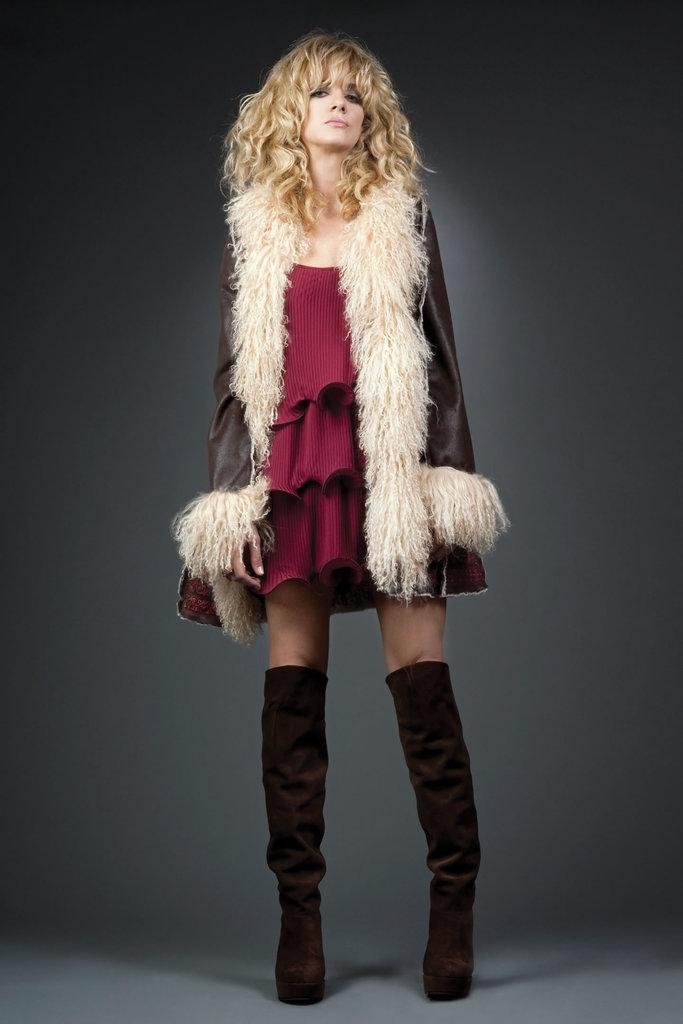Who is the main subject in the image? There is a woman in the center of the image. What type of clothing is the woman wearing? The woman is wearing a jacket and boots. What can be seen in the background of the image? There is a curtain in the background of the image. What type of sponge is the woman using to clean the plant in the image? There is no sponge or plant present in the image. How does the woman's grandmother feel about her outfit in the image? There is no grandmother present in the image, so it is impossible to determine her feelings about the woman's outfit. 